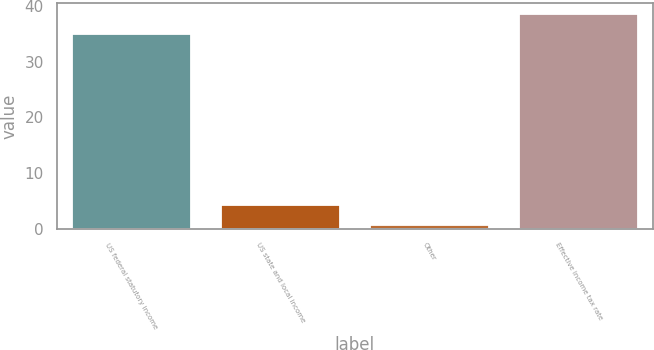Convert chart. <chart><loc_0><loc_0><loc_500><loc_500><bar_chart><fcel>US federal statutory income<fcel>US state and local income<fcel>Other<fcel>Effective income tax rate<nl><fcel>35<fcel>4.22<fcel>0.7<fcel>38.52<nl></chart> 